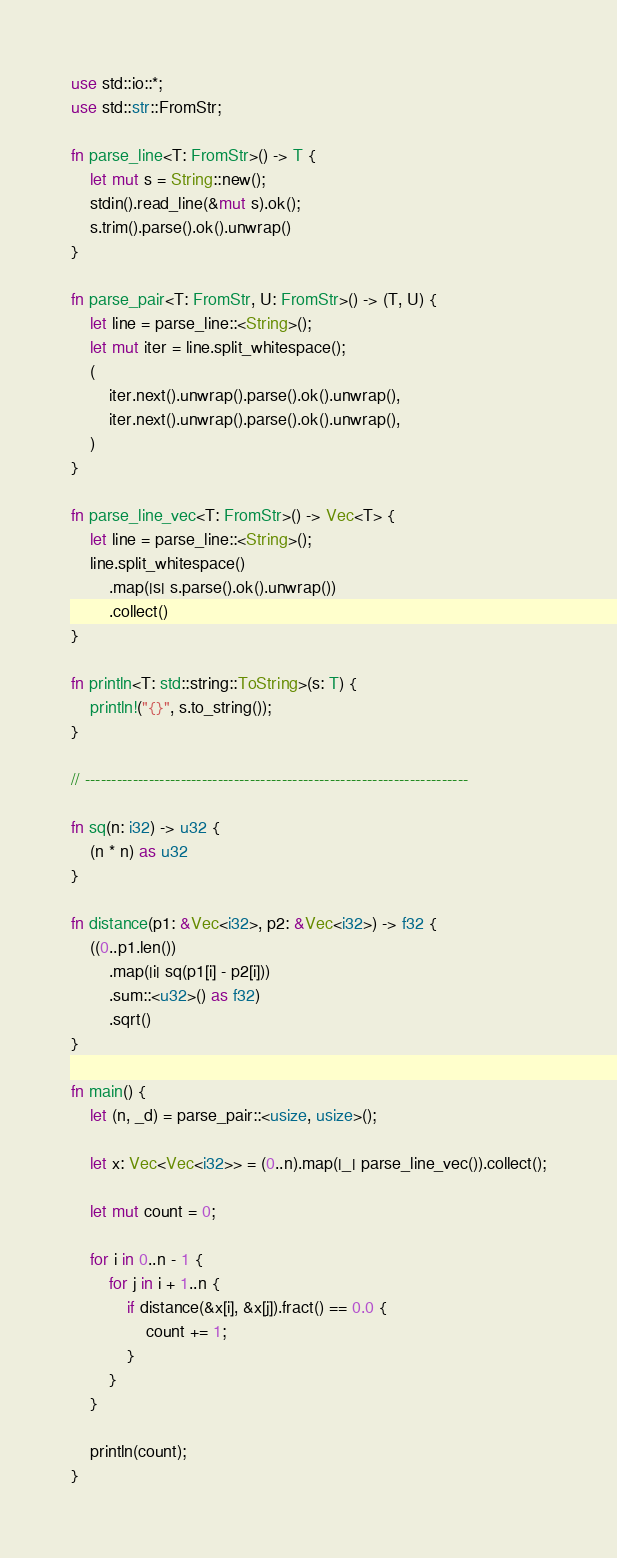Convert code to text. <code><loc_0><loc_0><loc_500><loc_500><_Rust_>use std::io::*;
use std::str::FromStr;

fn parse_line<T: FromStr>() -> T {
    let mut s = String::new();
    stdin().read_line(&mut s).ok();
    s.trim().parse().ok().unwrap()
}

fn parse_pair<T: FromStr, U: FromStr>() -> (T, U) {
    let line = parse_line::<String>();
    let mut iter = line.split_whitespace();
    (
        iter.next().unwrap().parse().ok().unwrap(),
        iter.next().unwrap().parse().ok().unwrap(),
    )
}

fn parse_line_vec<T: FromStr>() -> Vec<T> {
    let line = parse_line::<String>();
    line.split_whitespace()
        .map(|s| s.parse().ok().unwrap())
        .collect()
}

fn println<T: std::string::ToString>(s: T) {
    println!("{}", s.to_string());
}

// ------------------------------------------------------------------------

fn sq(n: i32) -> u32 {
    (n * n) as u32
}

fn distance(p1: &Vec<i32>, p2: &Vec<i32>) -> f32 {
    ((0..p1.len())
        .map(|i| sq(p1[i] - p2[i]))
        .sum::<u32>() as f32)
        .sqrt()
}

fn main() {
    let (n, _d) = parse_pair::<usize, usize>();

    let x: Vec<Vec<i32>> = (0..n).map(|_| parse_line_vec()).collect();

    let mut count = 0;

    for i in 0..n - 1 {
        for j in i + 1..n {
            if distance(&x[i], &x[j]).fract() == 0.0 {
                count += 1;
            }
        }
    }

    println(count);
}
</code> 